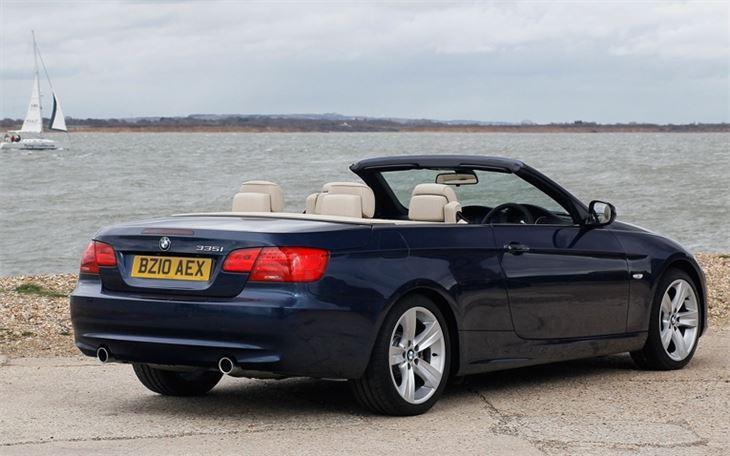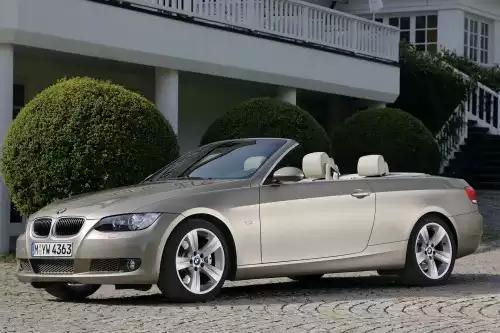The first image is the image on the left, the second image is the image on the right. For the images displayed, is the sentence "Two convertible sports cars are parked so that their license plates are visible, one blue with white seat headrests and one silver metallic." factually correct? Answer yes or no. Yes. The first image is the image on the left, the second image is the image on the right. Examine the images to the left and right. Is the description "An image shows a parked deep blue convertible with noone inside it." accurate? Answer yes or no. Yes. 